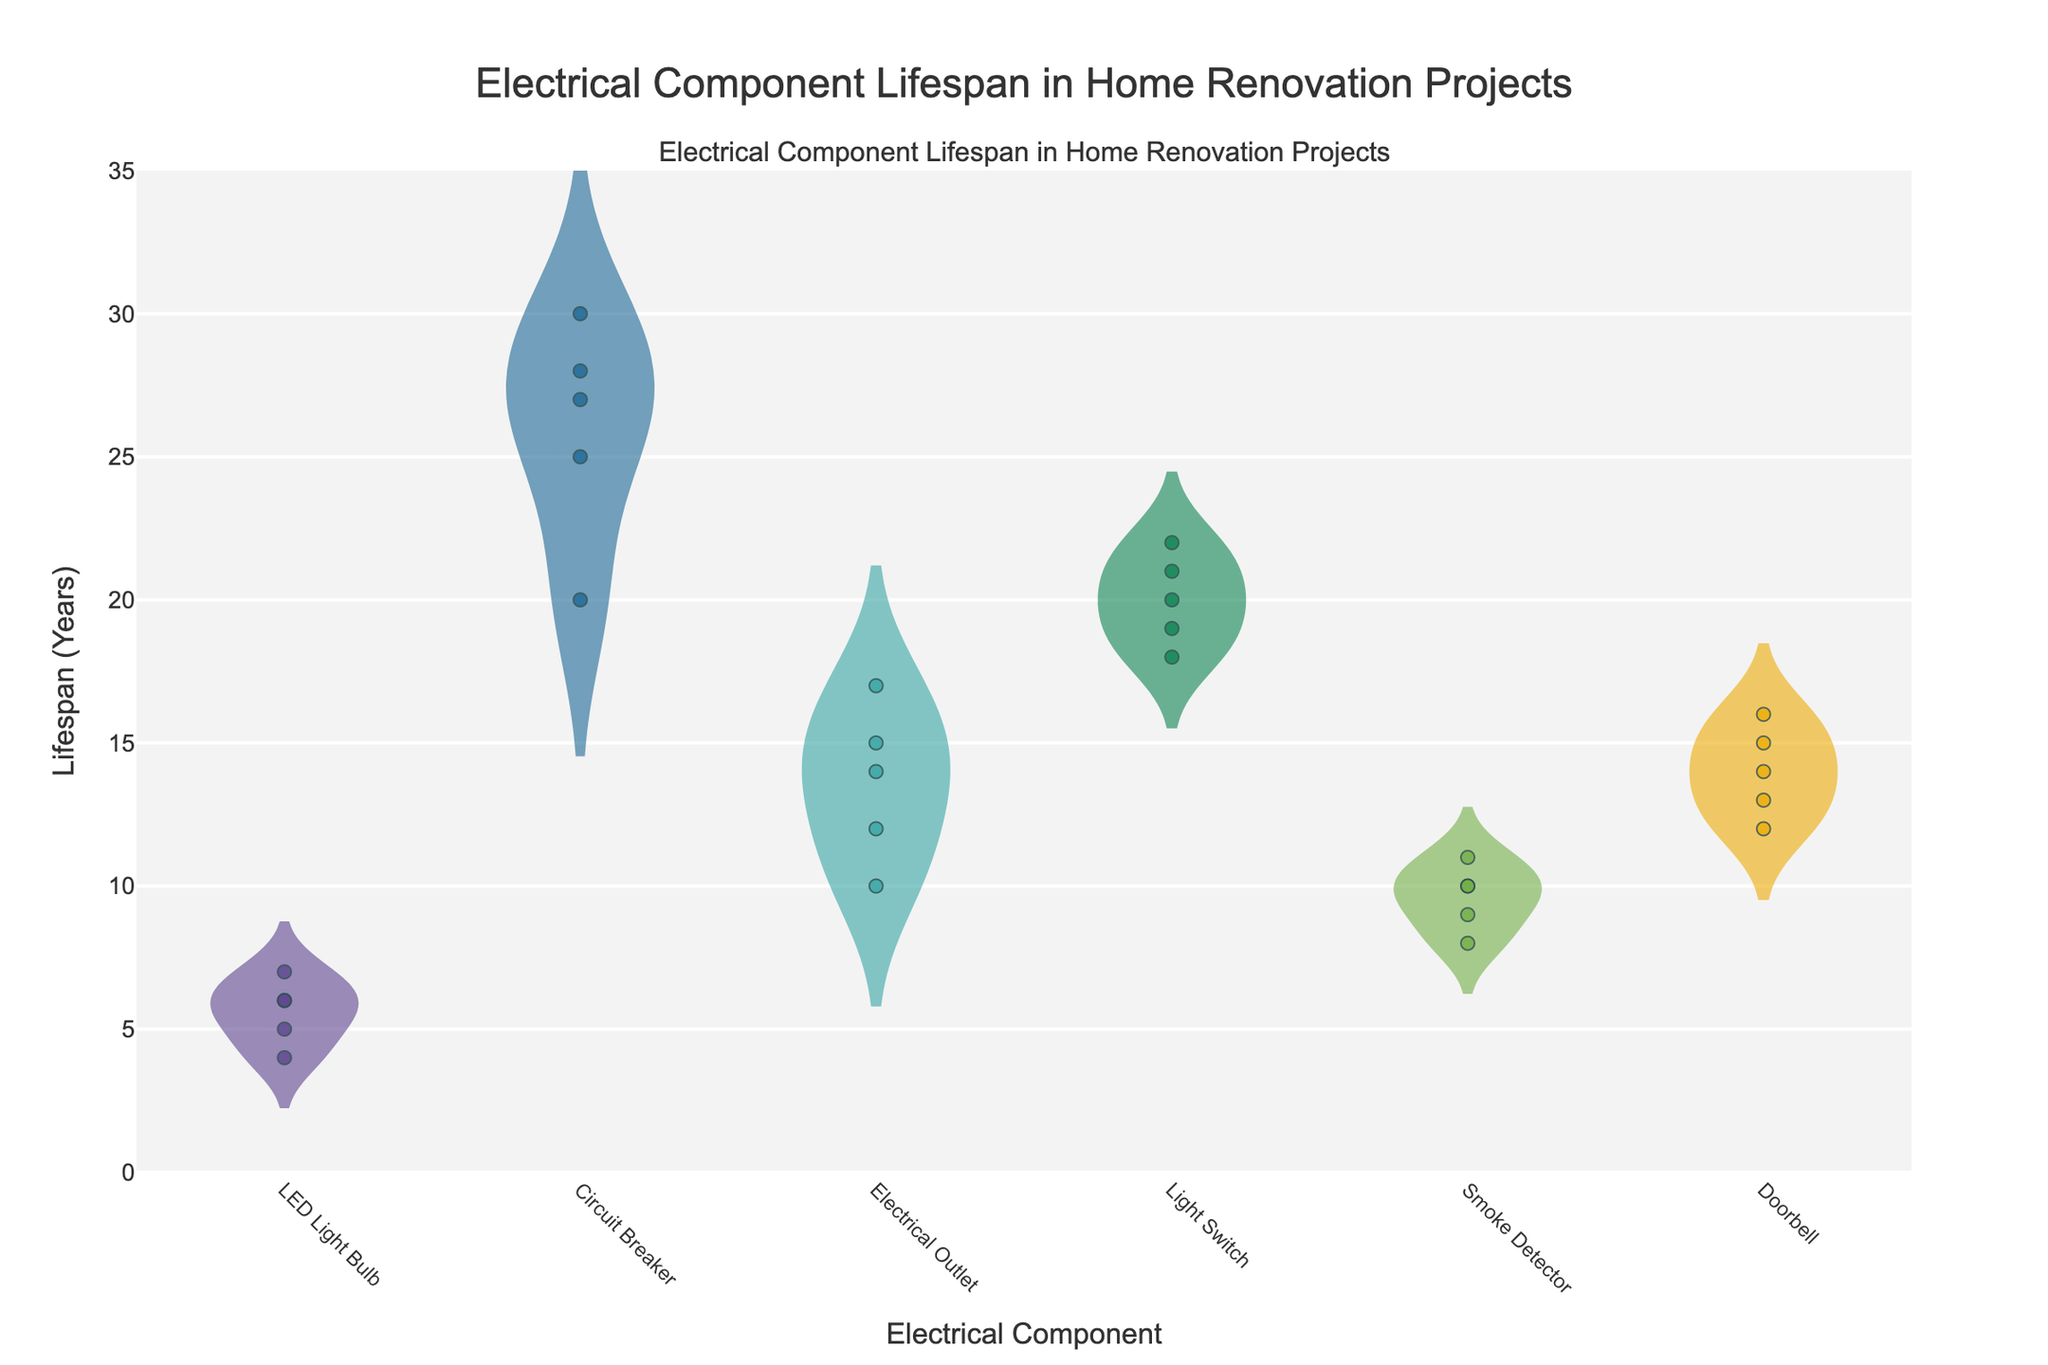What is the title of the plot? The title of the plot is located at the top center of the figure.
Answer: Electrical Component Lifespan in Home Renovation Projects What does the X-axis represent? The X-axis lists the categories of electrical components being measured.
Answer: Electrical Component What does the Y-axis represent? The Y-axis indicates the lifespan of electrical components in years.
Answer: Lifespan (Years) Which electrical component has the longest average lifespan? By looking at the mean lines in the violin plots, we can see which component reaches the highest average level on the Y-axis. The Circuit Breaker plot shows the highest average.
Answer: Circuit Breaker How many electrical components are presented in the plot? By counting the unique categories along the X-axis, we can determine the number of different electrical components.
Answer: 6 Which home renovation project has the longest recorded lifespan for a Smoke Detector? Checking the highest data points within the Smoke Detector's violin plot, we see the maximum point. The highest data point shows a lifespan of 11 years in the Living Room Makeover.
Answer: Living Room Makeover Which electrical component exhibits the widest range of lifespan years? The range is width of the violin and is determined by the minimum and maximum data points. The Circuit Breaker has the widest range from 20 to 30 years.
Answer: Circuit Breaker Comparing LED Light Bulb and Doorbell components, which has a higher median lifespan? The median lifespan is represented by the thick bar within the violin plot. The median of the LED Light Bulb is around 6 years, while that for the Doorbell is approximately 14 years.
Answer: Doorbell What is the average lifespan of Electrical Outlets and how does it compare to Light Switches? Calculate the average values by adding each value for Electrical Outlets (15, 17, 12, 14, 10) which sums to 68, and divide by 5 to get an average of 13.6. For Light Switches (20, 18, 21, 22, 19) the sum is 100, average is 20. Electrical Outlets have a lower average compared to Light Switches.
Answer: Electrical Outlets: 13.6, Light Switches: 20 Is there any component whose lifespan drastically varies depending on the renovation project? Identify substantial differences within individual violin plots. The LED Light Bulb shows significant variation from 4 to 7 years.
Answer: LED Light Bulb 